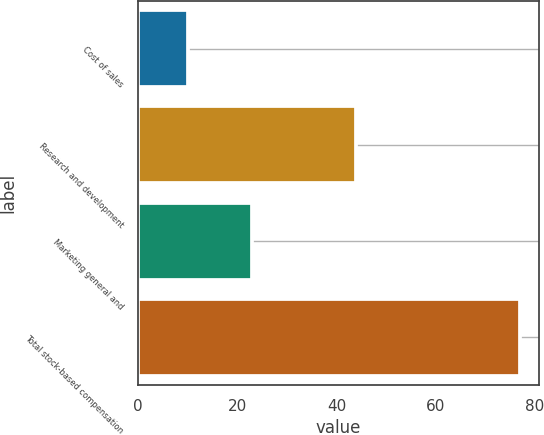Convert chart to OTSL. <chart><loc_0><loc_0><loc_500><loc_500><bar_chart><fcel>Cost of sales<fcel>Research and development<fcel>Marketing general and<fcel>Total stock-based compensation<nl><fcel>10<fcel>44<fcel>23<fcel>77<nl></chart> 